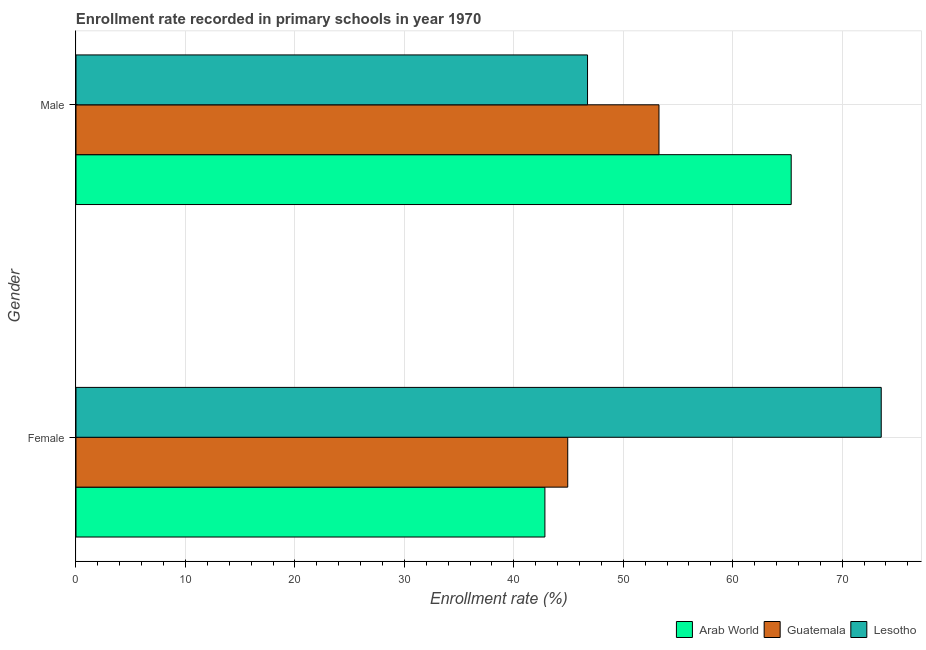How many different coloured bars are there?
Make the answer very short. 3. How many groups of bars are there?
Give a very brief answer. 2. What is the enrollment rate of male students in Arab World?
Provide a short and direct response. 65.35. Across all countries, what is the maximum enrollment rate of male students?
Provide a short and direct response. 65.35. Across all countries, what is the minimum enrollment rate of female students?
Keep it short and to the point. 42.84. In which country was the enrollment rate of male students maximum?
Ensure brevity in your answer.  Arab World. In which country was the enrollment rate of male students minimum?
Ensure brevity in your answer.  Lesotho. What is the total enrollment rate of male students in the graph?
Provide a succinct answer. 165.35. What is the difference between the enrollment rate of male students in Guatemala and that in Lesotho?
Provide a short and direct response. 6.53. What is the difference between the enrollment rate of male students in Guatemala and the enrollment rate of female students in Arab World?
Ensure brevity in your answer.  10.42. What is the average enrollment rate of female students per country?
Ensure brevity in your answer.  53.78. What is the difference between the enrollment rate of male students and enrollment rate of female students in Guatemala?
Your answer should be very brief. 8.34. What is the ratio of the enrollment rate of male students in Lesotho to that in Guatemala?
Offer a terse response. 0.88. In how many countries, is the enrollment rate of female students greater than the average enrollment rate of female students taken over all countries?
Your response must be concise. 1. What does the 1st bar from the top in Female represents?
Give a very brief answer. Lesotho. What does the 1st bar from the bottom in Female represents?
Offer a very short reply. Arab World. How many bars are there?
Your answer should be compact. 6. Are the values on the major ticks of X-axis written in scientific E-notation?
Your answer should be very brief. No. Does the graph contain any zero values?
Provide a succinct answer. No. How many legend labels are there?
Offer a terse response. 3. How are the legend labels stacked?
Keep it short and to the point. Horizontal. What is the title of the graph?
Offer a very short reply. Enrollment rate recorded in primary schools in year 1970. What is the label or title of the X-axis?
Your answer should be compact. Enrollment rate (%). What is the Enrollment rate (%) of Arab World in Female?
Your response must be concise. 42.84. What is the Enrollment rate (%) of Guatemala in Female?
Give a very brief answer. 44.93. What is the Enrollment rate (%) in Lesotho in Female?
Your response must be concise. 73.57. What is the Enrollment rate (%) of Arab World in Male?
Provide a succinct answer. 65.35. What is the Enrollment rate (%) in Guatemala in Male?
Keep it short and to the point. 53.27. What is the Enrollment rate (%) in Lesotho in Male?
Offer a terse response. 46.74. Across all Gender, what is the maximum Enrollment rate (%) in Arab World?
Provide a succinct answer. 65.35. Across all Gender, what is the maximum Enrollment rate (%) of Guatemala?
Offer a very short reply. 53.27. Across all Gender, what is the maximum Enrollment rate (%) of Lesotho?
Keep it short and to the point. 73.57. Across all Gender, what is the minimum Enrollment rate (%) in Arab World?
Offer a very short reply. 42.84. Across all Gender, what is the minimum Enrollment rate (%) in Guatemala?
Provide a short and direct response. 44.93. Across all Gender, what is the minimum Enrollment rate (%) in Lesotho?
Give a very brief answer. 46.74. What is the total Enrollment rate (%) in Arab World in the graph?
Your response must be concise. 108.19. What is the total Enrollment rate (%) of Guatemala in the graph?
Ensure brevity in your answer.  98.19. What is the total Enrollment rate (%) of Lesotho in the graph?
Ensure brevity in your answer.  120.31. What is the difference between the Enrollment rate (%) in Arab World in Female and that in Male?
Offer a very short reply. -22.5. What is the difference between the Enrollment rate (%) of Guatemala in Female and that in Male?
Keep it short and to the point. -8.34. What is the difference between the Enrollment rate (%) of Lesotho in Female and that in Male?
Make the answer very short. 26.83. What is the difference between the Enrollment rate (%) in Arab World in Female and the Enrollment rate (%) in Guatemala in Male?
Your answer should be compact. -10.42. What is the difference between the Enrollment rate (%) of Arab World in Female and the Enrollment rate (%) of Lesotho in Male?
Offer a terse response. -3.9. What is the difference between the Enrollment rate (%) in Guatemala in Female and the Enrollment rate (%) in Lesotho in Male?
Provide a short and direct response. -1.81. What is the average Enrollment rate (%) in Arab World per Gender?
Offer a very short reply. 54.09. What is the average Enrollment rate (%) of Guatemala per Gender?
Your answer should be very brief. 49.1. What is the average Enrollment rate (%) in Lesotho per Gender?
Give a very brief answer. 60.16. What is the difference between the Enrollment rate (%) of Arab World and Enrollment rate (%) of Guatemala in Female?
Provide a short and direct response. -2.09. What is the difference between the Enrollment rate (%) of Arab World and Enrollment rate (%) of Lesotho in Female?
Provide a short and direct response. -30.73. What is the difference between the Enrollment rate (%) of Guatemala and Enrollment rate (%) of Lesotho in Female?
Provide a succinct answer. -28.64. What is the difference between the Enrollment rate (%) of Arab World and Enrollment rate (%) of Guatemala in Male?
Provide a short and direct response. 12.08. What is the difference between the Enrollment rate (%) in Arab World and Enrollment rate (%) in Lesotho in Male?
Ensure brevity in your answer.  18.61. What is the difference between the Enrollment rate (%) in Guatemala and Enrollment rate (%) in Lesotho in Male?
Your response must be concise. 6.53. What is the ratio of the Enrollment rate (%) of Arab World in Female to that in Male?
Your response must be concise. 0.66. What is the ratio of the Enrollment rate (%) of Guatemala in Female to that in Male?
Make the answer very short. 0.84. What is the ratio of the Enrollment rate (%) of Lesotho in Female to that in Male?
Your response must be concise. 1.57. What is the difference between the highest and the second highest Enrollment rate (%) in Arab World?
Your response must be concise. 22.5. What is the difference between the highest and the second highest Enrollment rate (%) of Guatemala?
Give a very brief answer. 8.34. What is the difference between the highest and the second highest Enrollment rate (%) of Lesotho?
Give a very brief answer. 26.83. What is the difference between the highest and the lowest Enrollment rate (%) of Arab World?
Provide a succinct answer. 22.5. What is the difference between the highest and the lowest Enrollment rate (%) of Guatemala?
Your response must be concise. 8.34. What is the difference between the highest and the lowest Enrollment rate (%) in Lesotho?
Keep it short and to the point. 26.83. 